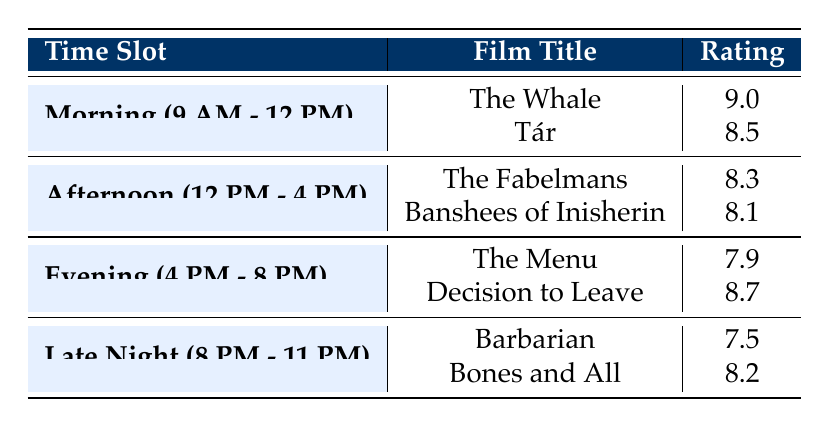What is the highest film rating in the morning time slot? The morning time slot includes two films: "The Whale" with a rating of 9.0 and "Tár" with a rating of 8.5. Comparing these, "The Whale" has the highest rating.
Answer: 9.0 How many films had a rating above 8.0? The table lists eight films in total. The films with ratings above 8.0 are "The Whale" (9.0), "Tár" (8.5), "Decision to Leave" (8.7), "Bones and All" (8.2), and "The Fabelmans" (8.3). Counting these, there are five films above 8.0.
Answer: 5 What is the average rating of films screened in the afternoon? The afternoon time slot features two films with ratings: "The Fabelmans" (8.3) and "Banshees of Inisherin" (8.1). To find the average, sum the ratings (8.3 + 8.1 = 16.4) and divide by the number of films (2). Thus, the average rating is 16.4 / 2 = 8.2.
Answer: 8.2 Did any film rated below 8.0 show in the evening time slot? The evening time slot contains "The Menu" (7.9) and "Decision to Leave" (8.7). Since "The Menu" has a rating below 8.0, the answer is yes.
Answer: Yes Which time slot had the lowest rated film? The lowest rated film is "Barbarian" (7.5) shown during the late night time slot (8 PM - 11 PM). Comparing the ratings across all time slots, "Barbarian" has the minimum rating.
Answer: Late Night (8 PM - 11 PM) 